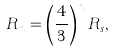Convert formula to latex. <formula><loc_0><loc_0><loc_500><loc_500>R _ { n } = \left ( \frac { 4 } { 3 } \right ) ^ { n } R _ { s } ,</formula> 